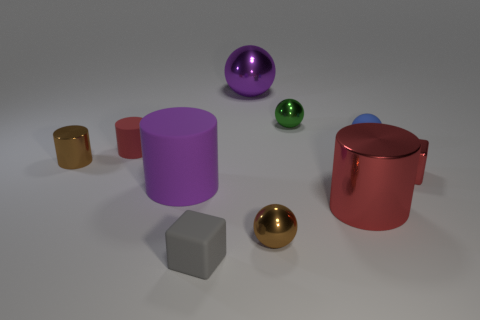Subtract all green spheres. How many spheres are left? 3 Subtract all yellow cylinders. Subtract all purple blocks. How many cylinders are left? 4 Subtract all blocks. How many objects are left? 8 Add 6 small rubber balls. How many small rubber balls are left? 7 Add 1 brown balls. How many brown balls exist? 2 Subtract 0 cyan cylinders. How many objects are left? 10 Subtract all big rubber balls. Subtract all red rubber cylinders. How many objects are left? 9 